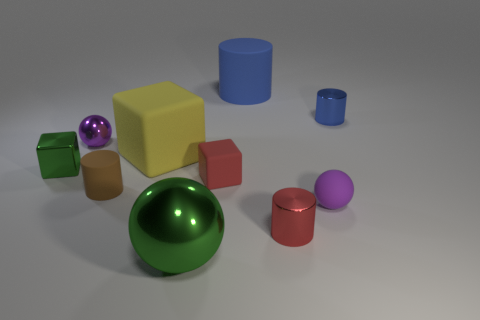Does the small matte thing that is to the left of the large yellow cube have the same color as the block right of the large rubber cube?
Your answer should be very brief. No. The large rubber object on the right side of the cube that is on the right side of the large cube is what shape?
Make the answer very short. Cylinder. What number of other things are the same color as the large rubber cube?
Provide a short and direct response. 0. Does the tiny ball that is in front of the small brown rubber object have the same material as the small purple object behind the green metallic block?
Provide a succinct answer. No. How big is the purple thing that is in front of the large cube?
Give a very brief answer. Small. There is another large object that is the same shape as the purple metal object; what is it made of?
Ensure brevity in your answer.  Metal. What shape is the big object on the left side of the large green metal sphere?
Provide a short and direct response. Cube. How many small purple shiny objects have the same shape as the red metal thing?
Offer a very short reply. 0. Are there an equal number of large blue things on the left side of the brown thing and large rubber cubes behind the small blue thing?
Give a very brief answer. Yes. Is there a tiny blue object made of the same material as the big sphere?
Provide a succinct answer. Yes. 